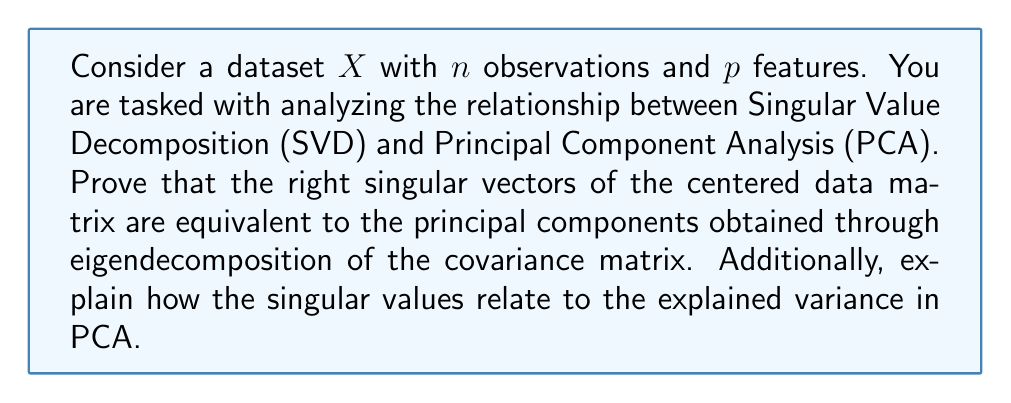Teach me how to tackle this problem. To demonstrate the relationship between SVD and PCA, we'll follow these steps:

1. Center the data matrix $X$:
Let $\bar{X}$ be the centered data matrix, where each column has zero mean.

2. Perform SVD on the centered data matrix:
$$\bar{X} = U\Sigma V^T$$
Where:
- $U$ is an $n \times n$ orthogonal matrix of left singular vectors
- $\Sigma$ is an $n \times p$ diagonal matrix of singular values
- $V$ is a $p \times p$ orthogonal matrix of right singular vectors

3. Calculate the covariance matrix:
$$C = \frac{1}{n-1}\bar{X}^T\bar{X}$$

4. Substitute the SVD of $\bar{X}$ into the covariance matrix:
$$C = \frac{1}{n-1}(U\Sigma V^T)^T(U\Sigma V^T)$$
$$C = \frac{1}{n-1}V\Sigma^T U^T U\Sigma V^T$$
$$C = \frac{1}{n-1}V\Sigma^T\Sigma V^T$$

Since $\Sigma$ is diagonal, $\Sigma^T\Sigma$ is also diagonal with entries $\sigma_i^2$.

5. Eigendecomposition of the covariance matrix:
$$C = V(\frac{1}{n-1}\Sigma^T\Sigma)V^T$$

This shows that $V$ contains the eigenvectors of $C$, which are the principal components in PCA.

6. Relationship between singular values and explained variance:
The eigenvalues of $C$ are $\lambda_i = \frac{\sigma_i^2}{n-1}$, where $\sigma_i$ are the singular values.

The proportion of variance explained by the $i$-th principal component is:
$$\frac{\lambda_i}{\sum_{j=1}^p \lambda_j} = \frac{\sigma_i^2}{\sum_{j=1}^p \sigma_j^2}$$

This demonstrates that the squared singular values are proportional to the variance explained by each principal component.
Answer: The right singular vectors (V) from SVD of the centered data matrix are equivalent to the principal components obtained through eigendecomposition of the covariance matrix. The squared singular values ($\sigma_i^2$) are proportional to the variance explained by each principal component, with the proportion of variance explained by the $i$-th component given by $\frac{\sigma_i^2}{\sum_{j=1}^p \sigma_j^2}$. 